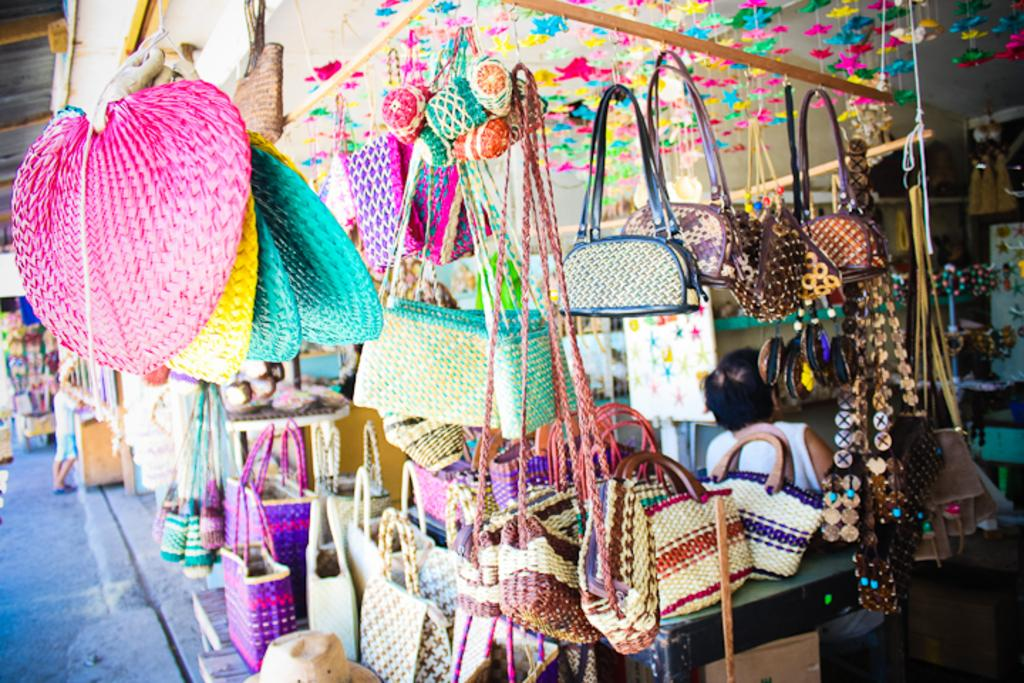What type of establishment is shown in the image? There is a store in the image. What can be found inside the store? There are objects placed in the store. Can you describe the person in the image? A person is standing at the left side of the image. What type of vegetable is the person holding in the image? There is no vegetable present in the image, and the person is not holding anything. What is the person's emotional state in the image? The person's emotional state cannot be determined from the image. Can you see any ducks in the image? There are no ducks present in the image. 